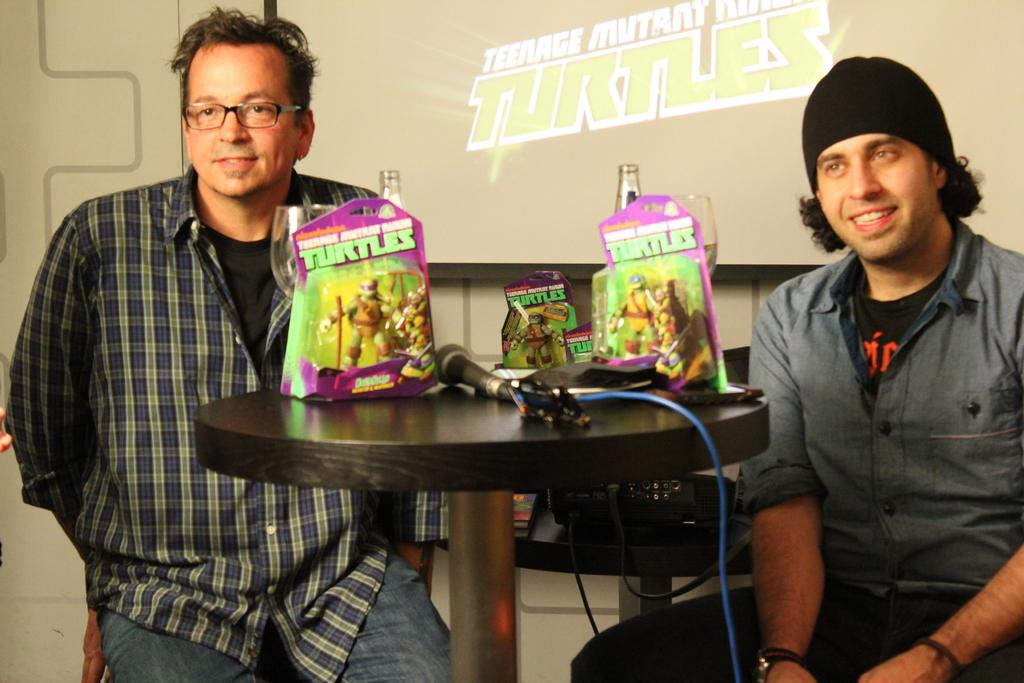How many people are in the image? There are two men in the image. What are the men doing in the image? The men are sitting together. What is present in the image besides the men? There is a table in the image. What can be seen on the table? There are many packets on the table, and they have "turtle" written on them. What type of wood is used to make the flag visible in the image? There is no flag present in the image, so it is not possible to determine the type of wood used to make it. 